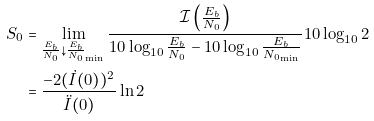Convert formula to latex. <formula><loc_0><loc_0><loc_500><loc_500>S _ { 0 } & = \lim _ { \frac { E _ { b } } { N _ { 0 } } \downarrow \frac { E _ { b } } { N _ { 0 } } _ { \min } } \frac { \mathcal { I } \left ( { \frac { E _ { b } } { N _ { 0 } } } \right ) } { 1 0 \log _ { 1 0 } \frac { E _ { b } } { N _ { 0 } } - 1 0 \log _ { 1 0 } \frac { E _ { b } } { { N _ { 0 } } _ { \min } } } 1 0 \log _ { 1 0 } 2 \\ & = \frac { - 2 ( \dot { I } ( 0 ) ) ^ { 2 } } { \ddot { I } ( 0 ) } \ln 2</formula> 